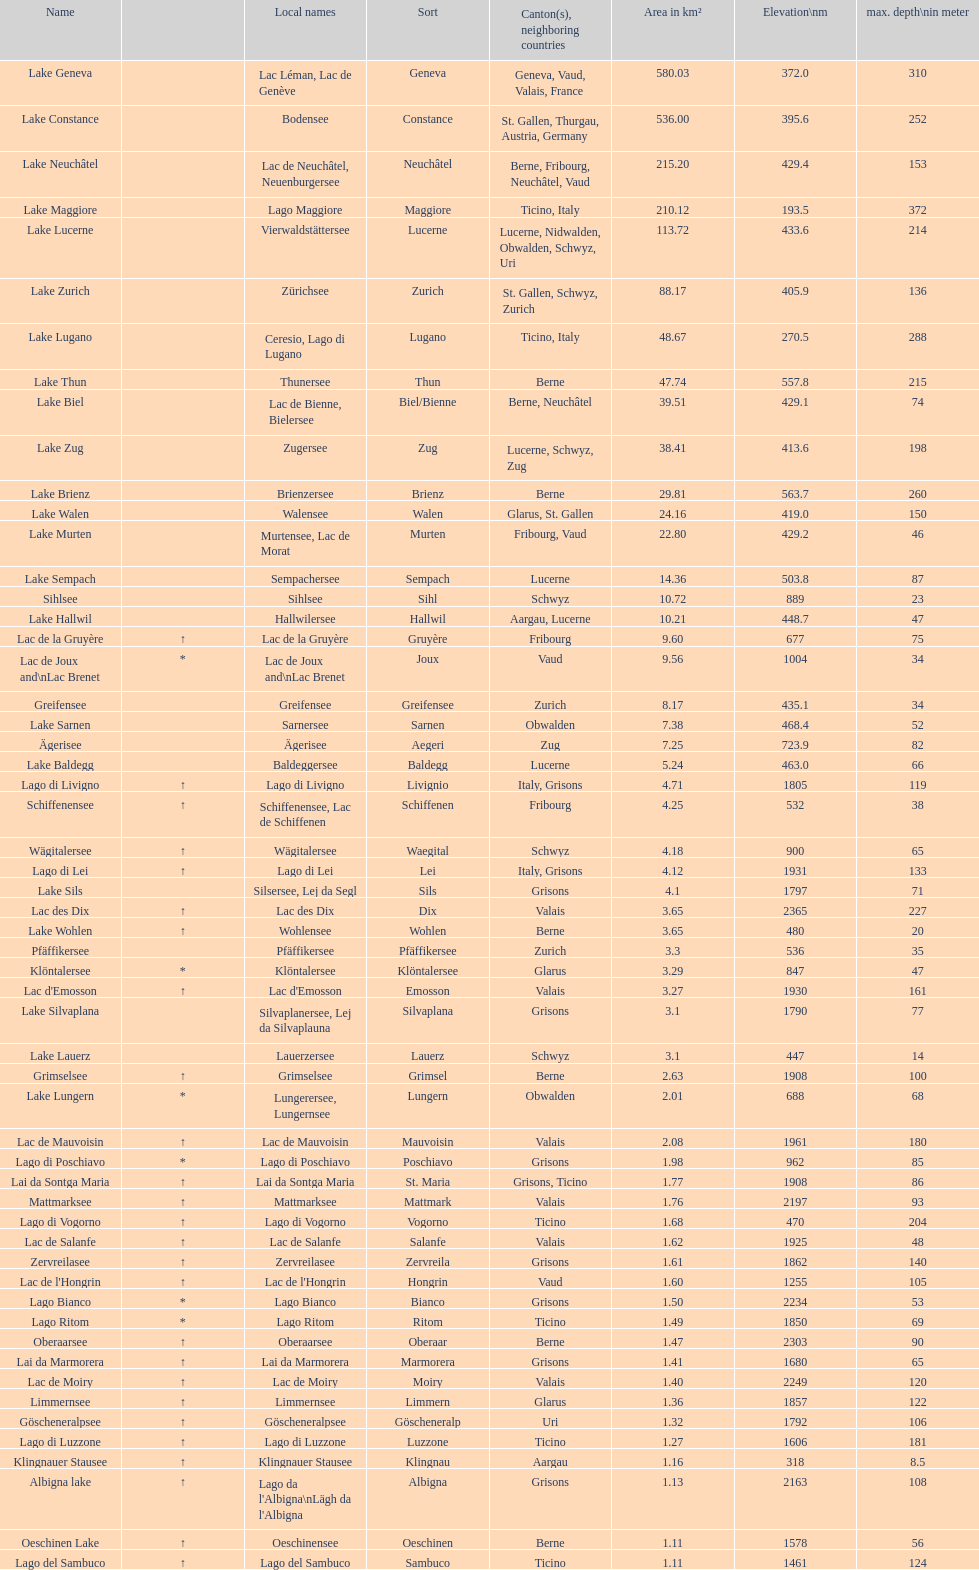How many lakes possess an area under 100 km squared? 51. 